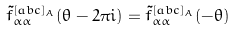<formula> <loc_0><loc_0><loc_500><loc_500>\tilde { f } ^ { [ a b c ] _ { A } } _ { \alpha \alpha } ( \theta - 2 \pi i ) = \tilde { f } ^ { [ a b c ] _ { A } } _ { \alpha \alpha } ( - \theta )</formula> 